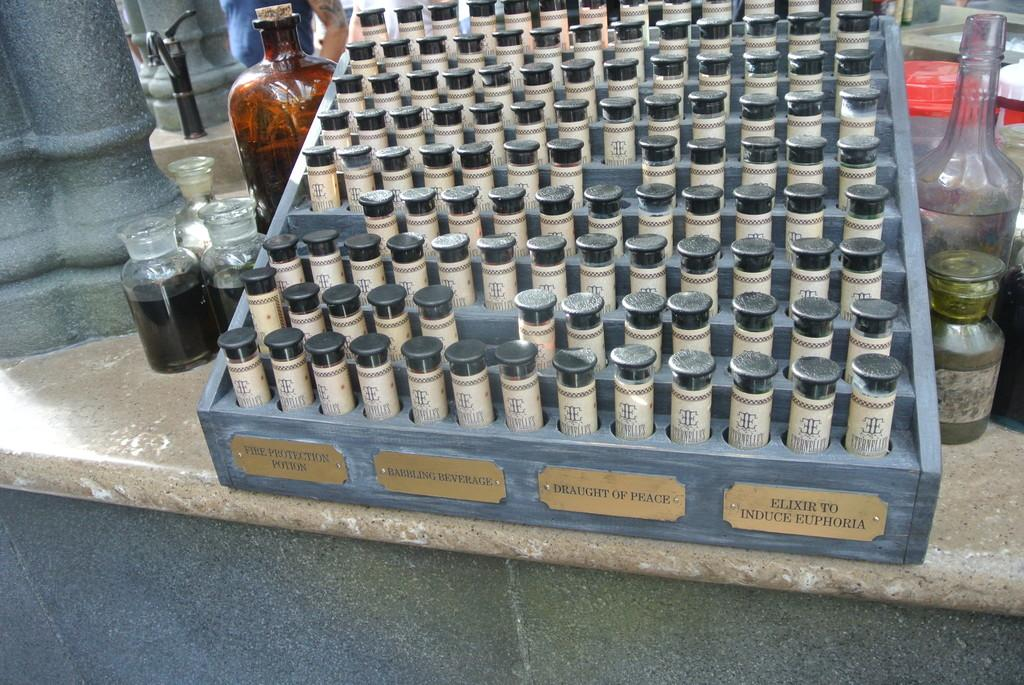<image>
Render a clear and concise summary of the photo. A collection of vials of potions and elixirs in rows. 